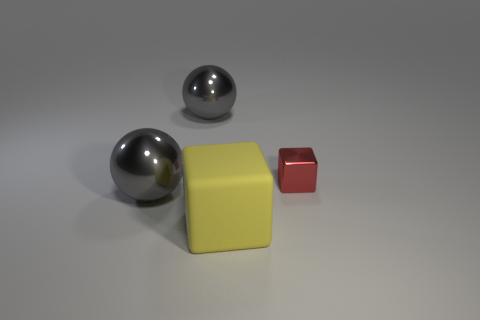Add 4 small blue cylinders. How many objects exist? 8 Add 4 large matte blocks. How many large matte blocks are left? 5 Add 2 large metallic balls. How many large metallic balls exist? 4 Subtract 0 red spheres. How many objects are left? 4 Subtract all red things. Subtract all large cyan metallic spheres. How many objects are left? 3 